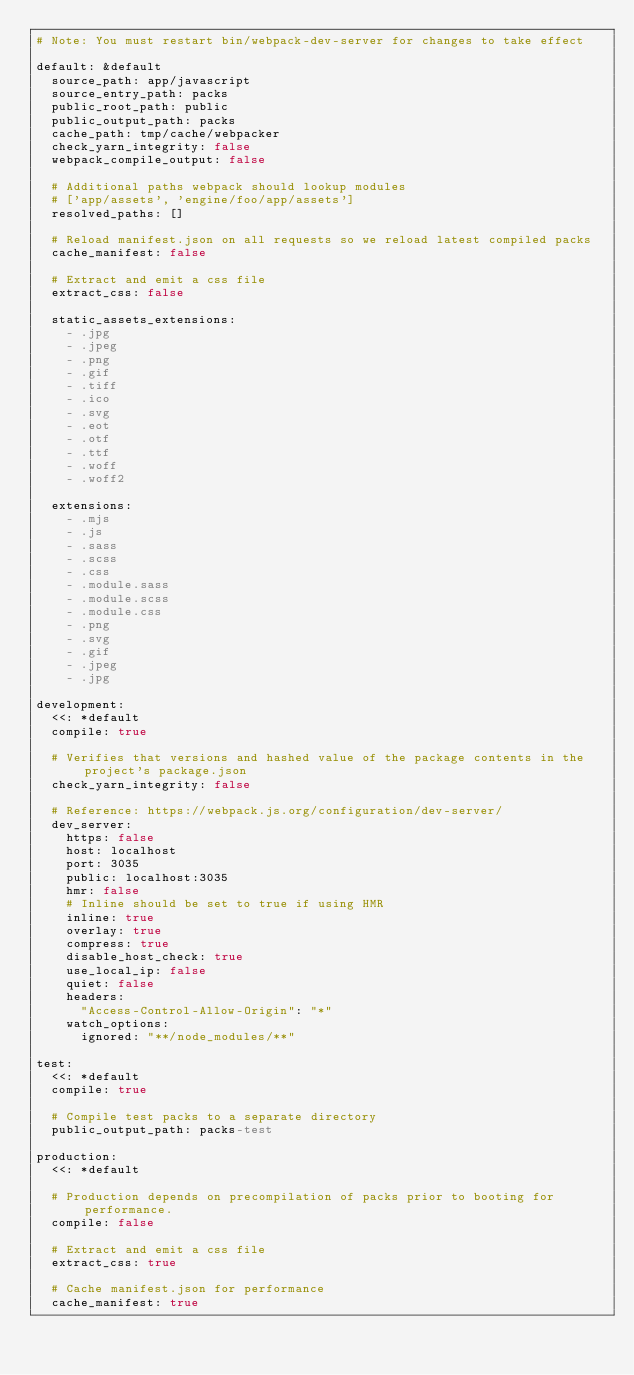Convert code to text. <code><loc_0><loc_0><loc_500><loc_500><_YAML_># Note: You must restart bin/webpack-dev-server for changes to take effect

default: &default
  source_path: app/javascript
  source_entry_path: packs
  public_root_path: public
  public_output_path: packs
  cache_path: tmp/cache/webpacker
  check_yarn_integrity: false
  webpack_compile_output: false

  # Additional paths webpack should lookup modules
  # ['app/assets', 'engine/foo/app/assets']
  resolved_paths: []

  # Reload manifest.json on all requests so we reload latest compiled packs
  cache_manifest: false

  # Extract and emit a css file
  extract_css: false

  static_assets_extensions:
    - .jpg
    - .jpeg
    - .png
    - .gif
    - .tiff
    - .ico
    - .svg
    - .eot
    - .otf
    - .ttf
    - .woff
    - .woff2

  extensions:
    - .mjs
    - .js
    - .sass
    - .scss
    - .css
    - .module.sass
    - .module.scss
    - .module.css
    - .png
    - .svg
    - .gif
    - .jpeg
    - .jpg

development:
  <<: *default
  compile: true

  # Verifies that versions and hashed value of the package contents in the project's package.json
  check_yarn_integrity: false

  # Reference: https://webpack.js.org/configuration/dev-server/
  dev_server:
    https: false
    host: localhost
    port: 3035
    public: localhost:3035
    hmr: false
    # Inline should be set to true if using HMR
    inline: true
    overlay: true
    compress: true
    disable_host_check: true
    use_local_ip: false
    quiet: false
    headers:
      "Access-Control-Allow-Origin": "*"
    watch_options:
      ignored: "**/node_modules/**"

test:
  <<: *default
  compile: true

  # Compile test packs to a separate directory
  public_output_path: packs-test

production:
  <<: *default

  # Production depends on precompilation of packs prior to booting for performance.
  compile: false

  # Extract and emit a css file
  extract_css: true

  # Cache manifest.json for performance
  cache_manifest: true
</code> 